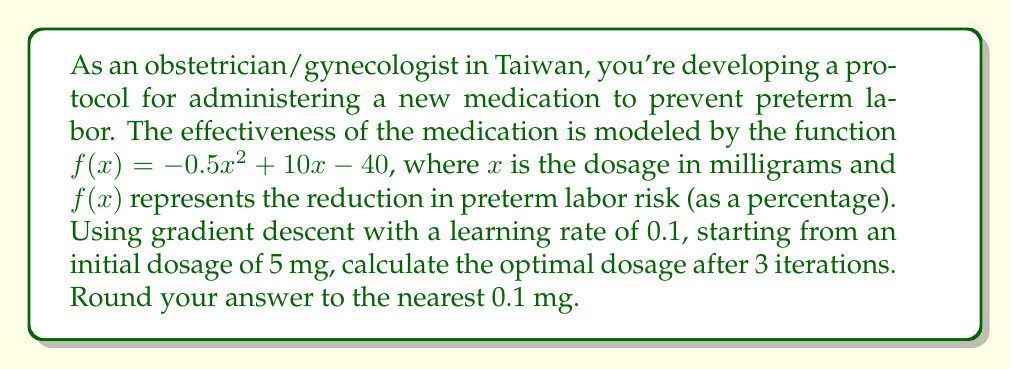Can you solve this math problem? To solve this problem using gradient descent, we'll follow these steps:

1) The gradient descent update rule is:
   $x_{n+1} = x_n - \alpha \cdot f'(x_n)$
   where $\alpha$ is the learning rate and $f'(x)$ is the derivative of $f(x)$.

2) First, let's find $f'(x)$:
   $f'(x) = -x + 10$

3) Now, we'll perform 3 iterations of gradient descent:

   Iteration 1:
   $x_1 = 5 - 0.1 \cdot f'(5)$
   $= 5 - 0.1 \cdot (-5 + 10)$
   $= 5 - 0.1 \cdot 5$
   $= 5 - 0.5 = 4.5$

   Iteration 2:
   $x_2 = 4.5 - 0.1 \cdot f'(4.5)$
   $= 4.5 - 0.1 \cdot (-4.5 + 10)$
   $= 4.5 - 0.1 \cdot 5.5$
   $= 4.5 - 0.55 = 3.95$

   Iteration 3:
   $x_3 = 3.95 - 0.1 \cdot f'(3.95)$
   $= 3.95 - 0.1 \cdot (-3.95 + 10)$
   $= 3.95 - 0.1 \cdot 6.05$
   $= 3.95 - 0.605 = 3.345$

4) Rounding to the nearest 0.1 mg gives us 3.3 mg.
Answer: 3.3 mg 